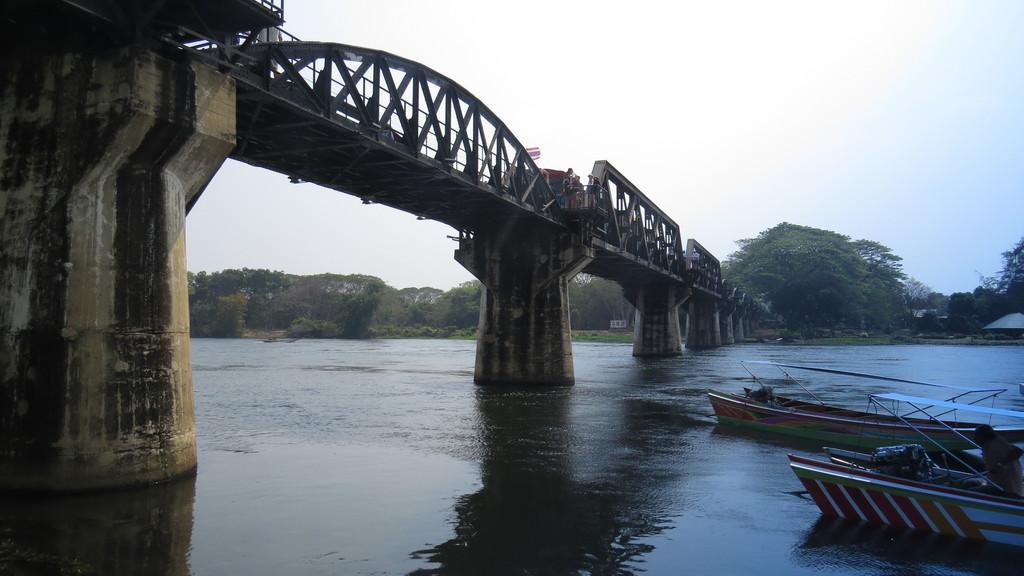How would you summarize this image in a sentence or two? In this image I can see the boats on the water. I can see the bridge. In the background, I can see the trees and the sky. 